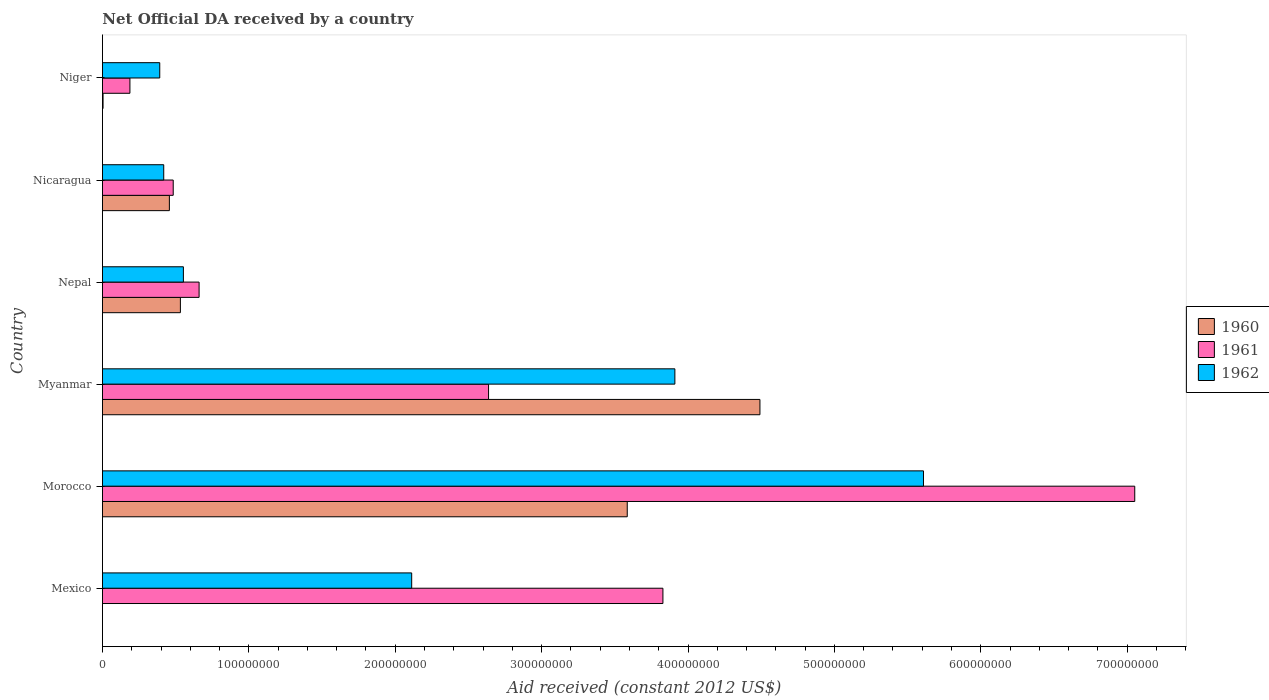How many groups of bars are there?
Provide a short and direct response. 6. Are the number of bars per tick equal to the number of legend labels?
Offer a terse response. No. Are the number of bars on each tick of the Y-axis equal?
Your answer should be very brief. No. What is the label of the 6th group of bars from the top?
Your response must be concise. Mexico. What is the net official development assistance aid received in 1961 in Nepal?
Offer a very short reply. 6.60e+07. Across all countries, what is the maximum net official development assistance aid received in 1960?
Make the answer very short. 4.49e+08. Across all countries, what is the minimum net official development assistance aid received in 1961?
Provide a succinct answer. 1.88e+07. In which country was the net official development assistance aid received in 1960 maximum?
Keep it short and to the point. Myanmar. What is the total net official development assistance aid received in 1962 in the graph?
Your response must be concise. 1.30e+09. What is the difference between the net official development assistance aid received in 1960 in Morocco and that in Niger?
Provide a short and direct response. 3.58e+08. What is the difference between the net official development assistance aid received in 1962 in Myanmar and the net official development assistance aid received in 1960 in Nepal?
Keep it short and to the point. 3.38e+08. What is the average net official development assistance aid received in 1961 per country?
Your answer should be very brief. 2.47e+08. What is the difference between the net official development assistance aid received in 1961 and net official development assistance aid received in 1962 in Myanmar?
Your answer should be very brief. -1.27e+08. What is the ratio of the net official development assistance aid received in 1962 in Myanmar to that in Nepal?
Your response must be concise. 7.07. Is the net official development assistance aid received in 1960 in Myanmar less than that in Niger?
Your answer should be very brief. No. Is the difference between the net official development assistance aid received in 1961 in Morocco and Myanmar greater than the difference between the net official development assistance aid received in 1962 in Morocco and Myanmar?
Your response must be concise. Yes. What is the difference between the highest and the second highest net official development assistance aid received in 1960?
Keep it short and to the point. 9.06e+07. What is the difference between the highest and the lowest net official development assistance aid received in 1960?
Keep it short and to the point. 4.49e+08. How many bars are there?
Your response must be concise. 17. Are all the bars in the graph horizontal?
Your response must be concise. Yes. Are the values on the major ticks of X-axis written in scientific E-notation?
Provide a short and direct response. No. Where does the legend appear in the graph?
Your answer should be very brief. Center right. How many legend labels are there?
Offer a terse response. 3. How are the legend labels stacked?
Keep it short and to the point. Vertical. What is the title of the graph?
Ensure brevity in your answer.  Net Official DA received by a country. Does "2005" appear as one of the legend labels in the graph?
Give a very brief answer. No. What is the label or title of the X-axis?
Offer a very short reply. Aid received (constant 2012 US$). What is the Aid received (constant 2012 US$) of 1961 in Mexico?
Offer a very short reply. 3.83e+08. What is the Aid received (constant 2012 US$) in 1962 in Mexico?
Provide a short and direct response. 2.11e+08. What is the Aid received (constant 2012 US$) in 1960 in Morocco?
Keep it short and to the point. 3.58e+08. What is the Aid received (constant 2012 US$) of 1961 in Morocco?
Offer a terse response. 7.05e+08. What is the Aid received (constant 2012 US$) in 1962 in Morocco?
Offer a very short reply. 5.61e+08. What is the Aid received (constant 2012 US$) of 1960 in Myanmar?
Provide a succinct answer. 4.49e+08. What is the Aid received (constant 2012 US$) in 1961 in Myanmar?
Offer a terse response. 2.64e+08. What is the Aid received (constant 2012 US$) of 1962 in Myanmar?
Offer a very short reply. 3.91e+08. What is the Aid received (constant 2012 US$) in 1960 in Nepal?
Ensure brevity in your answer.  5.32e+07. What is the Aid received (constant 2012 US$) of 1961 in Nepal?
Make the answer very short. 6.60e+07. What is the Aid received (constant 2012 US$) of 1962 in Nepal?
Give a very brief answer. 5.53e+07. What is the Aid received (constant 2012 US$) in 1960 in Nicaragua?
Provide a short and direct response. 4.57e+07. What is the Aid received (constant 2012 US$) in 1961 in Nicaragua?
Give a very brief answer. 4.83e+07. What is the Aid received (constant 2012 US$) in 1962 in Nicaragua?
Keep it short and to the point. 4.18e+07. What is the Aid received (constant 2012 US$) of 1960 in Niger?
Provide a short and direct response. 4.10e+05. What is the Aid received (constant 2012 US$) in 1961 in Niger?
Your answer should be compact. 1.88e+07. What is the Aid received (constant 2012 US$) in 1962 in Niger?
Your response must be concise. 3.91e+07. Across all countries, what is the maximum Aid received (constant 2012 US$) in 1960?
Provide a succinct answer. 4.49e+08. Across all countries, what is the maximum Aid received (constant 2012 US$) of 1961?
Provide a succinct answer. 7.05e+08. Across all countries, what is the maximum Aid received (constant 2012 US$) of 1962?
Offer a terse response. 5.61e+08. Across all countries, what is the minimum Aid received (constant 2012 US$) in 1961?
Provide a short and direct response. 1.88e+07. Across all countries, what is the minimum Aid received (constant 2012 US$) of 1962?
Keep it short and to the point. 3.91e+07. What is the total Aid received (constant 2012 US$) in 1960 in the graph?
Provide a succinct answer. 9.07e+08. What is the total Aid received (constant 2012 US$) of 1961 in the graph?
Keep it short and to the point. 1.48e+09. What is the total Aid received (constant 2012 US$) of 1962 in the graph?
Keep it short and to the point. 1.30e+09. What is the difference between the Aid received (constant 2012 US$) of 1961 in Mexico and that in Morocco?
Provide a succinct answer. -3.22e+08. What is the difference between the Aid received (constant 2012 US$) of 1962 in Mexico and that in Morocco?
Make the answer very short. -3.50e+08. What is the difference between the Aid received (constant 2012 US$) in 1961 in Mexico and that in Myanmar?
Offer a very short reply. 1.19e+08. What is the difference between the Aid received (constant 2012 US$) of 1962 in Mexico and that in Myanmar?
Give a very brief answer. -1.80e+08. What is the difference between the Aid received (constant 2012 US$) of 1961 in Mexico and that in Nepal?
Provide a short and direct response. 3.17e+08. What is the difference between the Aid received (constant 2012 US$) in 1962 in Mexico and that in Nepal?
Provide a short and direct response. 1.56e+08. What is the difference between the Aid received (constant 2012 US$) of 1961 in Mexico and that in Nicaragua?
Ensure brevity in your answer.  3.35e+08. What is the difference between the Aid received (constant 2012 US$) of 1962 in Mexico and that in Nicaragua?
Make the answer very short. 1.69e+08. What is the difference between the Aid received (constant 2012 US$) of 1961 in Mexico and that in Niger?
Provide a succinct answer. 3.64e+08. What is the difference between the Aid received (constant 2012 US$) in 1962 in Mexico and that in Niger?
Make the answer very short. 1.72e+08. What is the difference between the Aid received (constant 2012 US$) in 1960 in Morocco and that in Myanmar?
Offer a terse response. -9.06e+07. What is the difference between the Aid received (constant 2012 US$) in 1961 in Morocco and that in Myanmar?
Make the answer very short. 4.41e+08. What is the difference between the Aid received (constant 2012 US$) in 1962 in Morocco and that in Myanmar?
Make the answer very short. 1.70e+08. What is the difference between the Aid received (constant 2012 US$) of 1960 in Morocco and that in Nepal?
Keep it short and to the point. 3.05e+08. What is the difference between the Aid received (constant 2012 US$) of 1961 in Morocco and that in Nepal?
Your answer should be compact. 6.39e+08. What is the difference between the Aid received (constant 2012 US$) in 1962 in Morocco and that in Nepal?
Your answer should be very brief. 5.06e+08. What is the difference between the Aid received (constant 2012 US$) of 1960 in Morocco and that in Nicaragua?
Keep it short and to the point. 3.13e+08. What is the difference between the Aid received (constant 2012 US$) of 1961 in Morocco and that in Nicaragua?
Your answer should be very brief. 6.57e+08. What is the difference between the Aid received (constant 2012 US$) in 1962 in Morocco and that in Nicaragua?
Provide a short and direct response. 5.19e+08. What is the difference between the Aid received (constant 2012 US$) in 1960 in Morocco and that in Niger?
Provide a short and direct response. 3.58e+08. What is the difference between the Aid received (constant 2012 US$) of 1961 in Morocco and that in Niger?
Ensure brevity in your answer.  6.86e+08. What is the difference between the Aid received (constant 2012 US$) in 1962 in Morocco and that in Niger?
Offer a terse response. 5.22e+08. What is the difference between the Aid received (constant 2012 US$) in 1960 in Myanmar and that in Nepal?
Offer a terse response. 3.96e+08. What is the difference between the Aid received (constant 2012 US$) of 1961 in Myanmar and that in Nepal?
Provide a short and direct response. 1.98e+08. What is the difference between the Aid received (constant 2012 US$) of 1962 in Myanmar and that in Nepal?
Make the answer very short. 3.36e+08. What is the difference between the Aid received (constant 2012 US$) of 1960 in Myanmar and that in Nicaragua?
Make the answer very short. 4.03e+08. What is the difference between the Aid received (constant 2012 US$) in 1961 in Myanmar and that in Nicaragua?
Your answer should be compact. 2.15e+08. What is the difference between the Aid received (constant 2012 US$) of 1962 in Myanmar and that in Nicaragua?
Make the answer very short. 3.49e+08. What is the difference between the Aid received (constant 2012 US$) of 1960 in Myanmar and that in Niger?
Make the answer very short. 4.49e+08. What is the difference between the Aid received (constant 2012 US$) of 1961 in Myanmar and that in Niger?
Your answer should be compact. 2.45e+08. What is the difference between the Aid received (constant 2012 US$) in 1962 in Myanmar and that in Niger?
Make the answer very short. 3.52e+08. What is the difference between the Aid received (constant 2012 US$) in 1960 in Nepal and that in Nicaragua?
Make the answer very short. 7.52e+06. What is the difference between the Aid received (constant 2012 US$) in 1961 in Nepal and that in Nicaragua?
Your answer should be very brief. 1.77e+07. What is the difference between the Aid received (constant 2012 US$) of 1962 in Nepal and that in Nicaragua?
Ensure brevity in your answer.  1.34e+07. What is the difference between the Aid received (constant 2012 US$) of 1960 in Nepal and that in Niger?
Ensure brevity in your answer.  5.28e+07. What is the difference between the Aid received (constant 2012 US$) of 1961 in Nepal and that in Niger?
Ensure brevity in your answer.  4.72e+07. What is the difference between the Aid received (constant 2012 US$) of 1962 in Nepal and that in Niger?
Your answer should be very brief. 1.62e+07. What is the difference between the Aid received (constant 2012 US$) in 1960 in Nicaragua and that in Niger?
Offer a very short reply. 4.53e+07. What is the difference between the Aid received (constant 2012 US$) in 1961 in Nicaragua and that in Niger?
Give a very brief answer. 2.96e+07. What is the difference between the Aid received (constant 2012 US$) of 1962 in Nicaragua and that in Niger?
Provide a short and direct response. 2.72e+06. What is the difference between the Aid received (constant 2012 US$) of 1961 in Mexico and the Aid received (constant 2012 US$) of 1962 in Morocco?
Keep it short and to the point. -1.78e+08. What is the difference between the Aid received (constant 2012 US$) of 1961 in Mexico and the Aid received (constant 2012 US$) of 1962 in Myanmar?
Your response must be concise. -8.16e+06. What is the difference between the Aid received (constant 2012 US$) of 1961 in Mexico and the Aid received (constant 2012 US$) of 1962 in Nepal?
Make the answer very short. 3.28e+08. What is the difference between the Aid received (constant 2012 US$) of 1961 in Mexico and the Aid received (constant 2012 US$) of 1962 in Nicaragua?
Provide a short and direct response. 3.41e+08. What is the difference between the Aid received (constant 2012 US$) in 1961 in Mexico and the Aid received (constant 2012 US$) in 1962 in Niger?
Offer a terse response. 3.44e+08. What is the difference between the Aid received (constant 2012 US$) of 1960 in Morocco and the Aid received (constant 2012 US$) of 1961 in Myanmar?
Offer a terse response. 9.47e+07. What is the difference between the Aid received (constant 2012 US$) in 1960 in Morocco and the Aid received (constant 2012 US$) in 1962 in Myanmar?
Offer a terse response. -3.25e+07. What is the difference between the Aid received (constant 2012 US$) in 1961 in Morocco and the Aid received (constant 2012 US$) in 1962 in Myanmar?
Offer a terse response. 3.14e+08. What is the difference between the Aid received (constant 2012 US$) in 1960 in Morocco and the Aid received (constant 2012 US$) in 1961 in Nepal?
Your answer should be very brief. 2.92e+08. What is the difference between the Aid received (constant 2012 US$) in 1960 in Morocco and the Aid received (constant 2012 US$) in 1962 in Nepal?
Your answer should be compact. 3.03e+08. What is the difference between the Aid received (constant 2012 US$) of 1961 in Morocco and the Aid received (constant 2012 US$) of 1962 in Nepal?
Offer a very short reply. 6.50e+08. What is the difference between the Aid received (constant 2012 US$) of 1960 in Morocco and the Aid received (constant 2012 US$) of 1961 in Nicaragua?
Offer a terse response. 3.10e+08. What is the difference between the Aid received (constant 2012 US$) of 1960 in Morocco and the Aid received (constant 2012 US$) of 1962 in Nicaragua?
Your response must be concise. 3.17e+08. What is the difference between the Aid received (constant 2012 US$) of 1961 in Morocco and the Aid received (constant 2012 US$) of 1962 in Nicaragua?
Your answer should be compact. 6.63e+08. What is the difference between the Aid received (constant 2012 US$) in 1960 in Morocco and the Aid received (constant 2012 US$) in 1961 in Niger?
Give a very brief answer. 3.40e+08. What is the difference between the Aid received (constant 2012 US$) in 1960 in Morocco and the Aid received (constant 2012 US$) in 1962 in Niger?
Provide a short and direct response. 3.19e+08. What is the difference between the Aid received (constant 2012 US$) in 1961 in Morocco and the Aid received (constant 2012 US$) in 1962 in Niger?
Provide a short and direct response. 6.66e+08. What is the difference between the Aid received (constant 2012 US$) in 1960 in Myanmar and the Aid received (constant 2012 US$) in 1961 in Nepal?
Offer a very short reply. 3.83e+08. What is the difference between the Aid received (constant 2012 US$) in 1960 in Myanmar and the Aid received (constant 2012 US$) in 1962 in Nepal?
Keep it short and to the point. 3.94e+08. What is the difference between the Aid received (constant 2012 US$) of 1961 in Myanmar and the Aid received (constant 2012 US$) of 1962 in Nepal?
Offer a terse response. 2.08e+08. What is the difference between the Aid received (constant 2012 US$) of 1960 in Myanmar and the Aid received (constant 2012 US$) of 1961 in Nicaragua?
Offer a terse response. 4.01e+08. What is the difference between the Aid received (constant 2012 US$) in 1960 in Myanmar and the Aid received (constant 2012 US$) in 1962 in Nicaragua?
Give a very brief answer. 4.07e+08. What is the difference between the Aid received (constant 2012 US$) in 1961 in Myanmar and the Aid received (constant 2012 US$) in 1962 in Nicaragua?
Offer a terse response. 2.22e+08. What is the difference between the Aid received (constant 2012 US$) in 1960 in Myanmar and the Aid received (constant 2012 US$) in 1961 in Niger?
Make the answer very short. 4.30e+08. What is the difference between the Aid received (constant 2012 US$) of 1960 in Myanmar and the Aid received (constant 2012 US$) of 1962 in Niger?
Offer a terse response. 4.10e+08. What is the difference between the Aid received (constant 2012 US$) of 1961 in Myanmar and the Aid received (constant 2012 US$) of 1962 in Niger?
Your answer should be compact. 2.25e+08. What is the difference between the Aid received (constant 2012 US$) of 1960 in Nepal and the Aid received (constant 2012 US$) of 1961 in Nicaragua?
Keep it short and to the point. 4.90e+06. What is the difference between the Aid received (constant 2012 US$) in 1960 in Nepal and the Aid received (constant 2012 US$) in 1962 in Nicaragua?
Make the answer very short. 1.14e+07. What is the difference between the Aid received (constant 2012 US$) of 1961 in Nepal and the Aid received (constant 2012 US$) of 1962 in Nicaragua?
Keep it short and to the point. 2.42e+07. What is the difference between the Aid received (constant 2012 US$) in 1960 in Nepal and the Aid received (constant 2012 US$) in 1961 in Niger?
Make the answer very short. 3.45e+07. What is the difference between the Aid received (constant 2012 US$) in 1960 in Nepal and the Aid received (constant 2012 US$) in 1962 in Niger?
Provide a short and direct response. 1.41e+07. What is the difference between the Aid received (constant 2012 US$) of 1961 in Nepal and the Aid received (constant 2012 US$) of 1962 in Niger?
Ensure brevity in your answer.  2.69e+07. What is the difference between the Aid received (constant 2012 US$) in 1960 in Nicaragua and the Aid received (constant 2012 US$) in 1961 in Niger?
Provide a succinct answer. 2.70e+07. What is the difference between the Aid received (constant 2012 US$) of 1960 in Nicaragua and the Aid received (constant 2012 US$) of 1962 in Niger?
Make the answer very short. 6.58e+06. What is the difference between the Aid received (constant 2012 US$) in 1961 in Nicaragua and the Aid received (constant 2012 US$) in 1962 in Niger?
Keep it short and to the point. 9.20e+06. What is the average Aid received (constant 2012 US$) of 1960 per country?
Offer a very short reply. 1.51e+08. What is the average Aid received (constant 2012 US$) in 1961 per country?
Provide a short and direct response. 2.47e+08. What is the average Aid received (constant 2012 US$) in 1962 per country?
Provide a short and direct response. 2.17e+08. What is the difference between the Aid received (constant 2012 US$) of 1961 and Aid received (constant 2012 US$) of 1962 in Mexico?
Provide a short and direct response. 1.72e+08. What is the difference between the Aid received (constant 2012 US$) of 1960 and Aid received (constant 2012 US$) of 1961 in Morocco?
Your answer should be compact. -3.47e+08. What is the difference between the Aid received (constant 2012 US$) of 1960 and Aid received (constant 2012 US$) of 1962 in Morocco?
Offer a terse response. -2.02e+08. What is the difference between the Aid received (constant 2012 US$) of 1961 and Aid received (constant 2012 US$) of 1962 in Morocco?
Offer a very short reply. 1.44e+08. What is the difference between the Aid received (constant 2012 US$) in 1960 and Aid received (constant 2012 US$) in 1961 in Myanmar?
Make the answer very short. 1.85e+08. What is the difference between the Aid received (constant 2012 US$) in 1960 and Aid received (constant 2012 US$) in 1962 in Myanmar?
Ensure brevity in your answer.  5.81e+07. What is the difference between the Aid received (constant 2012 US$) of 1961 and Aid received (constant 2012 US$) of 1962 in Myanmar?
Give a very brief answer. -1.27e+08. What is the difference between the Aid received (constant 2012 US$) in 1960 and Aid received (constant 2012 US$) in 1961 in Nepal?
Ensure brevity in your answer.  -1.28e+07. What is the difference between the Aid received (constant 2012 US$) of 1960 and Aid received (constant 2012 US$) of 1962 in Nepal?
Your answer should be compact. -2.05e+06. What is the difference between the Aid received (constant 2012 US$) of 1961 and Aid received (constant 2012 US$) of 1962 in Nepal?
Your answer should be compact. 1.07e+07. What is the difference between the Aid received (constant 2012 US$) of 1960 and Aid received (constant 2012 US$) of 1961 in Nicaragua?
Ensure brevity in your answer.  -2.62e+06. What is the difference between the Aid received (constant 2012 US$) in 1960 and Aid received (constant 2012 US$) in 1962 in Nicaragua?
Offer a terse response. 3.86e+06. What is the difference between the Aid received (constant 2012 US$) in 1961 and Aid received (constant 2012 US$) in 1962 in Nicaragua?
Keep it short and to the point. 6.48e+06. What is the difference between the Aid received (constant 2012 US$) of 1960 and Aid received (constant 2012 US$) of 1961 in Niger?
Offer a very short reply. -1.84e+07. What is the difference between the Aid received (constant 2012 US$) in 1960 and Aid received (constant 2012 US$) in 1962 in Niger?
Ensure brevity in your answer.  -3.87e+07. What is the difference between the Aid received (constant 2012 US$) in 1961 and Aid received (constant 2012 US$) in 1962 in Niger?
Provide a short and direct response. -2.04e+07. What is the ratio of the Aid received (constant 2012 US$) of 1961 in Mexico to that in Morocco?
Keep it short and to the point. 0.54. What is the ratio of the Aid received (constant 2012 US$) in 1962 in Mexico to that in Morocco?
Your response must be concise. 0.38. What is the ratio of the Aid received (constant 2012 US$) of 1961 in Mexico to that in Myanmar?
Your answer should be compact. 1.45. What is the ratio of the Aid received (constant 2012 US$) of 1962 in Mexico to that in Myanmar?
Your answer should be very brief. 0.54. What is the ratio of the Aid received (constant 2012 US$) of 1961 in Mexico to that in Nepal?
Your answer should be compact. 5.8. What is the ratio of the Aid received (constant 2012 US$) in 1962 in Mexico to that in Nepal?
Offer a terse response. 3.82. What is the ratio of the Aid received (constant 2012 US$) in 1961 in Mexico to that in Nicaragua?
Offer a very short reply. 7.92. What is the ratio of the Aid received (constant 2012 US$) of 1962 in Mexico to that in Nicaragua?
Your response must be concise. 5.05. What is the ratio of the Aid received (constant 2012 US$) in 1961 in Mexico to that in Niger?
Keep it short and to the point. 20.41. What is the ratio of the Aid received (constant 2012 US$) of 1962 in Mexico to that in Niger?
Ensure brevity in your answer.  5.4. What is the ratio of the Aid received (constant 2012 US$) of 1960 in Morocco to that in Myanmar?
Make the answer very short. 0.8. What is the ratio of the Aid received (constant 2012 US$) in 1961 in Morocco to that in Myanmar?
Your answer should be compact. 2.67. What is the ratio of the Aid received (constant 2012 US$) of 1962 in Morocco to that in Myanmar?
Make the answer very short. 1.43. What is the ratio of the Aid received (constant 2012 US$) of 1960 in Morocco to that in Nepal?
Provide a succinct answer. 6.73. What is the ratio of the Aid received (constant 2012 US$) in 1961 in Morocco to that in Nepal?
Keep it short and to the point. 10.68. What is the ratio of the Aid received (constant 2012 US$) in 1962 in Morocco to that in Nepal?
Your answer should be very brief. 10.15. What is the ratio of the Aid received (constant 2012 US$) of 1960 in Morocco to that in Nicaragua?
Offer a terse response. 7.84. What is the ratio of the Aid received (constant 2012 US$) of 1961 in Morocco to that in Nicaragua?
Ensure brevity in your answer.  14.59. What is the ratio of the Aid received (constant 2012 US$) of 1962 in Morocco to that in Nicaragua?
Keep it short and to the point. 13.4. What is the ratio of the Aid received (constant 2012 US$) in 1960 in Morocco to that in Niger?
Your response must be concise. 874.39. What is the ratio of the Aid received (constant 2012 US$) in 1961 in Morocco to that in Niger?
Make the answer very short. 37.59. What is the ratio of the Aid received (constant 2012 US$) in 1962 in Morocco to that in Niger?
Your response must be concise. 14.33. What is the ratio of the Aid received (constant 2012 US$) in 1960 in Myanmar to that in Nepal?
Provide a succinct answer. 8.44. What is the ratio of the Aid received (constant 2012 US$) of 1961 in Myanmar to that in Nepal?
Offer a terse response. 4. What is the ratio of the Aid received (constant 2012 US$) in 1962 in Myanmar to that in Nepal?
Ensure brevity in your answer.  7.07. What is the ratio of the Aid received (constant 2012 US$) in 1960 in Myanmar to that in Nicaragua?
Offer a very short reply. 9.83. What is the ratio of the Aid received (constant 2012 US$) of 1961 in Myanmar to that in Nicaragua?
Provide a short and direct response. 5.46. What is the ratio of the Aid received (constant 2012 US$) of 1962 in Myanmar to that in Nicaragua?
Offer a very short reply. 9.34. What is the ratio of the Aid received (constant 2012 US$) in 1960 in Myanmar to that in Niger?
Give a very brief answer. 1095.46. What is the ratio of the Aid received (constant 2012 US$) of 1961 in Myanmar to that in Niger?
Your answer should be very brief. 14.06. What is the ratio of the Aid received (constant 2012 US$) of 1962 in Myanmar to that in Niger?
Your response must be concise. 9.99. What is the ratio of the Aid received (constant 2012 US$) of 1960 in Nepal to that in Nicaragua?
Your response must be concise. 1.16. What is the ratio of the Aid received (constant 2012 US$) of 1961 in Nepal to that in Nicaragua?
Your answer should be very brief. 1.37. What is the ratio of the Aid received (constant 2012 US$) in 1962 in Nepal to that in Nicaragua?
Provide a short and direct response. 1.32. What is the ratio of the Aid received (constant 2012 US$) of 1960 in Nepal to that in Niger?
Give a very brief answer. 129.83. What is the ratio of the Aid received (constant 2012 US$) in 1961 in Nepal to that in Niger?
Give a very brief answer. 3.52. What is the ratio of the Aid received (constant 2012 US$) in 1962 in Nepal to that in Niger?
Offer a very short reply. 1.41. What is the ratio of the Aid received (constant 2012 US$) of 1960 in Nicaragua to that in Niger?
Your answer should be very brief. 111.49. What is the ratio of the Aid received (constant 2012 US$) of 1961 in Nicaragua to that in Niger?
Keep it short and to the point. 2.58. What is the ratio of the Aid received (constant 2012 US$) in 1962 in Nicaragua to that in Niger?
Offer a terse response. 1.07. What is the difference between the highest and the second highest Aid received (constant 2012 US$) of 1960?
Offer a very short reply. 9.06e+07. What is the difference between the highest and the second highest Aid received (constant 2012 US$) in 1961?
Your answer should be compact. 3.22e+08. What is the difference between the highest and the second highest Aid received (constant 2012 US$) of 1962?
Make the answer very short. 1.70e+08. What is the difference between the highest and the lowest Aid received (constant 2012 US$) in 1960?
Ensure brevity in your answer.  4.49e+08. What is the difference between the highest and the lowest Aid received (constant 2012 US$) in 1961?
Give a very brief answer. 6.86e+08. What is the difference between the highest and the lowest Aid received (constant 2012 US$) in 1962?
Offer a very short reply. 5.22e+08. 